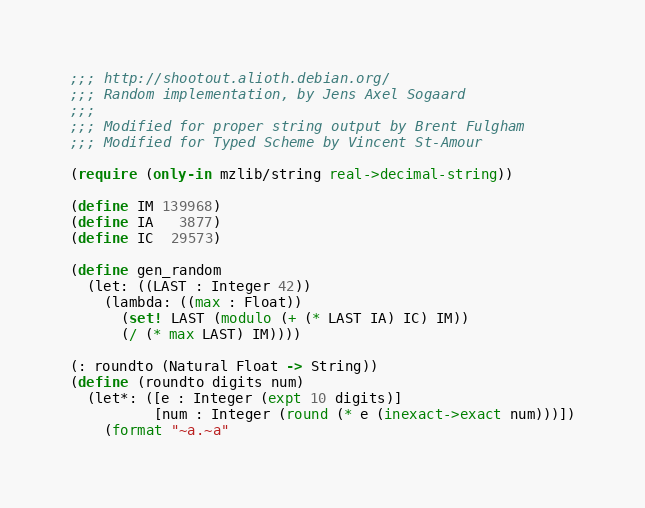Convert code to text. <code><loc_0><loc_0><loc_500><loc_500><_Racket_>;;; http://shootout.alioth.debian.org/
;;; Random implementation, by Jens Axel Sogaard
;;;
;;; Modified for proper string output by Brent Fulgham
;;; Modified for Typed Scheme by Vincent St-Amour

(require (only-in mzlib/string real->decimal-string))

(define IM 139968)
(define IA   3877)
(define IC  29573)

(define gen_random
  (let: ((LAST : Integer 42))
    (lambda: ((max : Float))
      (set! LAST (modulo (+ (* LAST IA) IC) IM))
      (/ (* max LAST) IM))))

(: roundto (Natural Float -> String))
(define (roundto digits num)
  (let*: ([e : Integer (expt 10 digits)]
          [num : Integer (round (* e (inexact->exact num)))])
    (format "~a.~a"</code> 